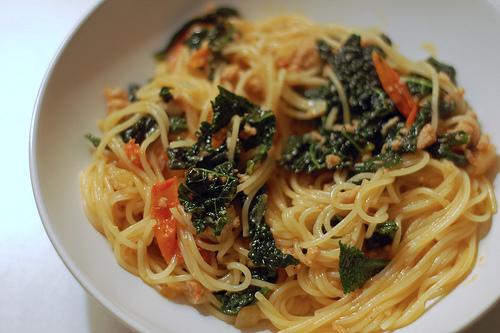<image>
Is there a spinach on the noodle? Yes. Looking at the image, I can see the spinach is positioned on top of the noodle, with the noodle providing support. 